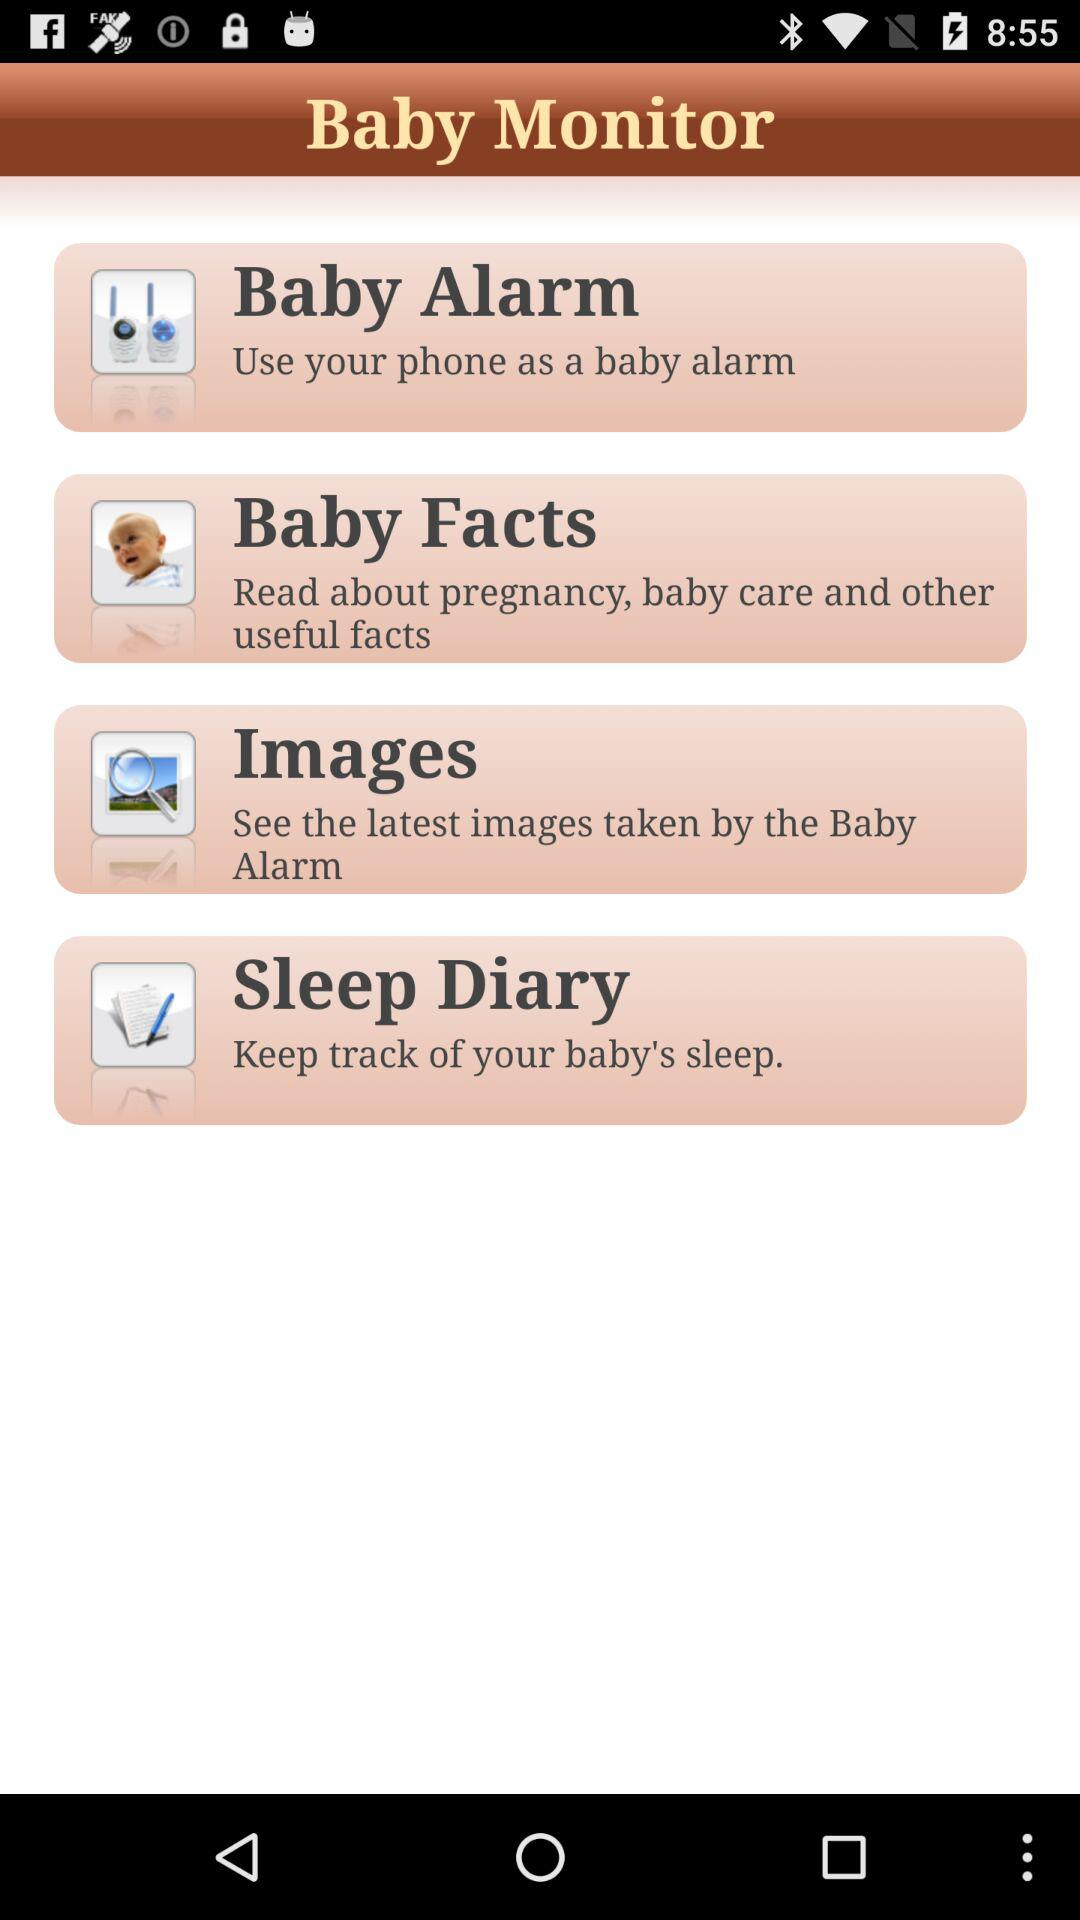What is the application name? The application name is "Baby Monitor". 